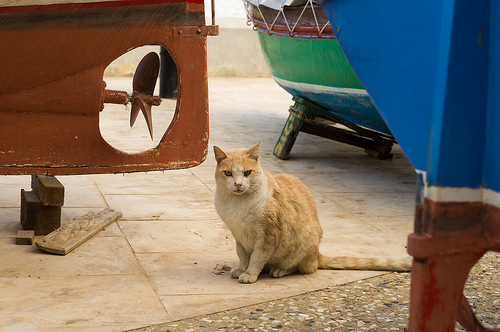<image>
Is the cat on the boat? No. The cat is not positioned on the boat. They may be near each other, but the cat is not supported by or resting on top of the boat. Where is the cat in relation to the propeller? Is it in front of the propeller? Yes. The cat is positioned in front of the propeller, appearing closer to the camera viewpoint. 